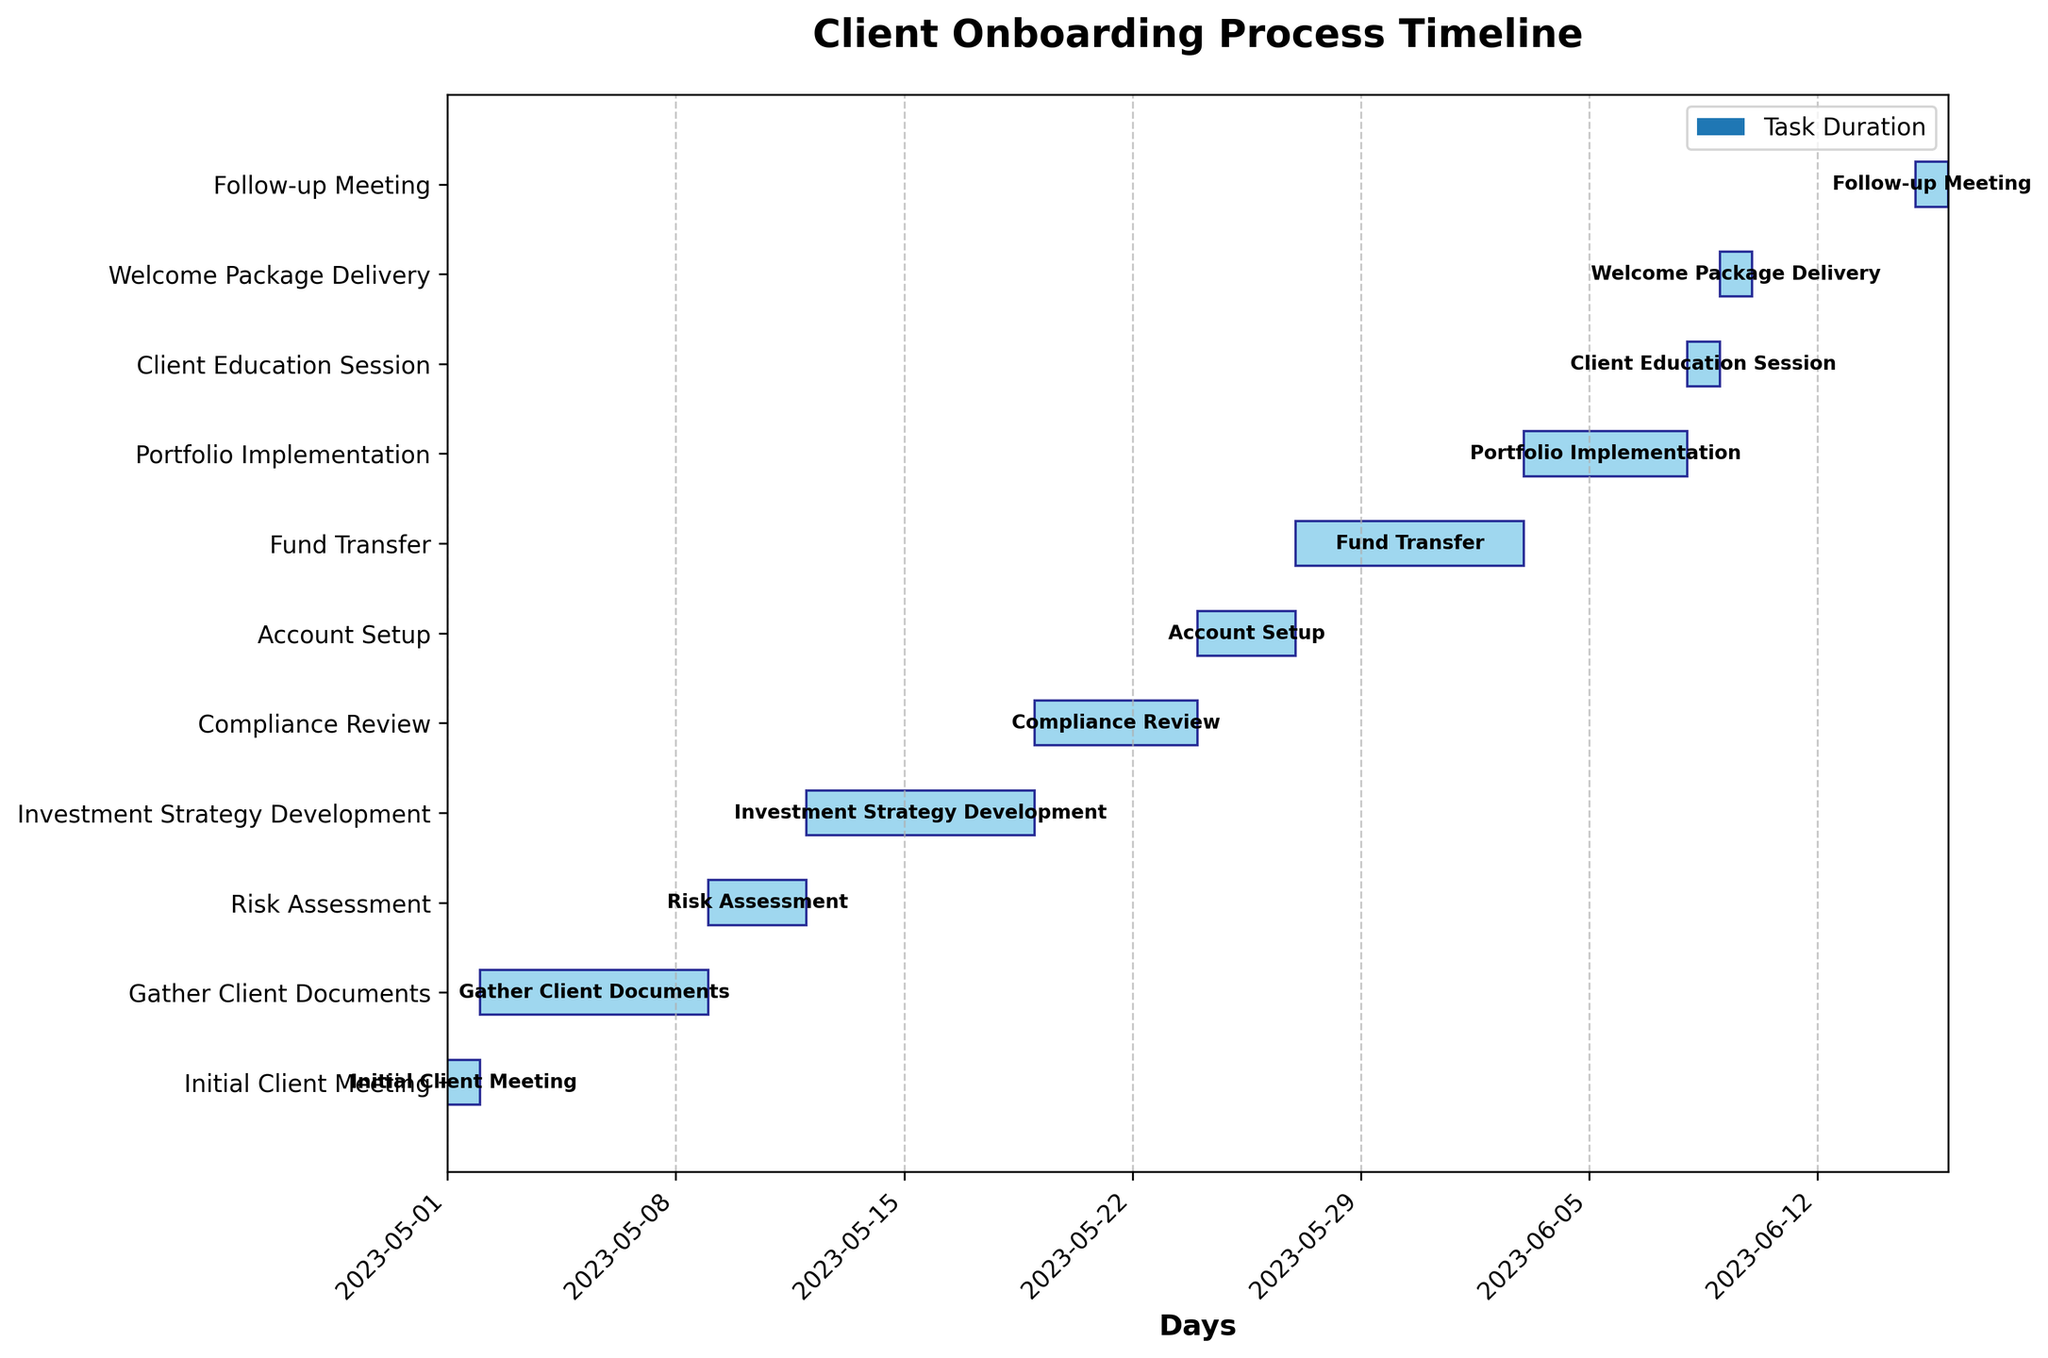When does the Investment Strategy Development task begin? The start date for the Investment Strategy Development task is indicated in the beginning of the corresponding horizontal bar in the Gantt chart.
Answer: 2023-05-12 How much time is allocated for the Compliance Review task? The duration of the Compliance Review task can be observed by the length of its corresponding bar, which is marked with a specific number of days.
Answer: 5 days Which task lasts the longest? By comparing the lengths of all the horizontal bars, the task with the longest duration can be identified.
Answer: Gather Client Documents How many tasks have a duration of exactly one day? Count the number of bars that span only one unit on the Gantt chart, which correspond to tasks that last for only one day.
Answer: 4 tasks What is the total duration of the onboarding process in days? The total duration is the difference between the end date of the last task (Follow-up Meeting) and the start date of the first task (Initial Client Meeting) added by one. Computation: (2023-06-15 - 2023-05-01) + 1 = 46 days.
Answer: 46 days Which tasks run consecutively without overlap? Consecutive, non-overlapping tasks can be identified visually by checking if the end date of one task matches the start date of the next task.
Answer: Initial Client Meeting & Gather Client Documents, Compliance Review & Account Setup How many tasks start in May? Count the bars on the chart that begin within the calendar range of May.
Answer: 8 tasks Which task ends closest to the end of May? Look for tasks whose end dates are near the last day of May and identify the one that finishes nearest to May 31st.
Answer: Fund Transfer How many tasks are planned between the Client Education Session and the Follow-up Meeting? Identify the tasks that fall within the date range from the end date of the Client Education Session to the start date of the Follow-up Meeting.
Answer: 1 task (Welcome Package Delivery) On which day does the entire client onboarding process finish? The process finishes on the end date of the last task on the chart, which is the Follow-up Meeting.
Answer: 2023-06-15 